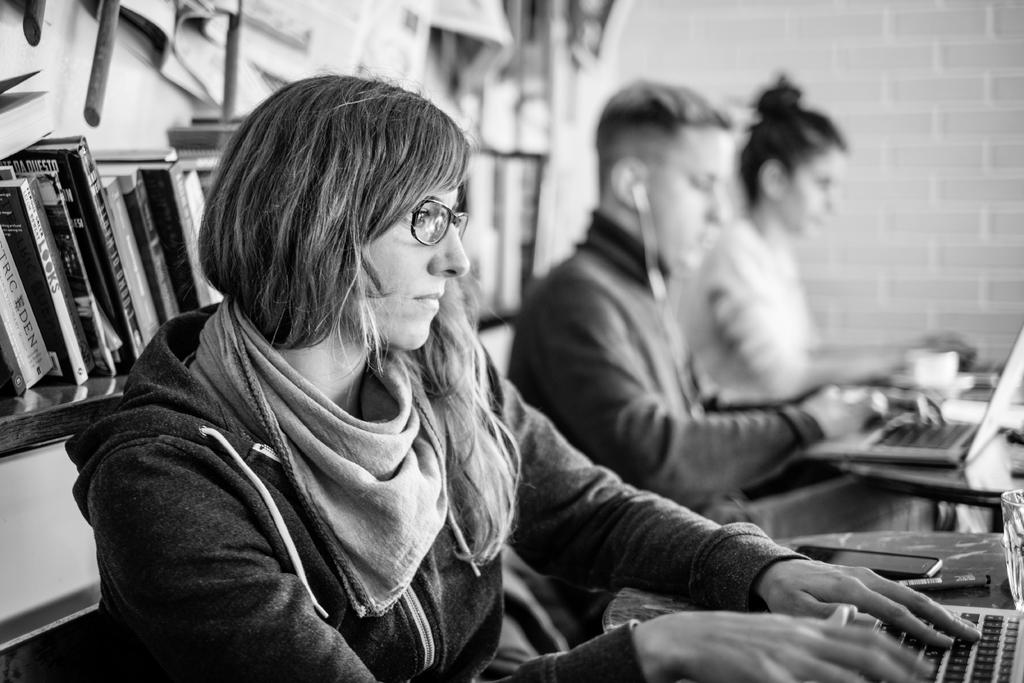<image>
Share a concise interpretation of the image provided. a black and white photo of a trio of people typing at their computers with books behind them with a lot of blurriness, but one book reads LOOKS. 